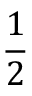Convert formula to latex. <formula><loc_0><loc_0><loc_500><loc_500>\frac { 1 } { 2 }</formula> 